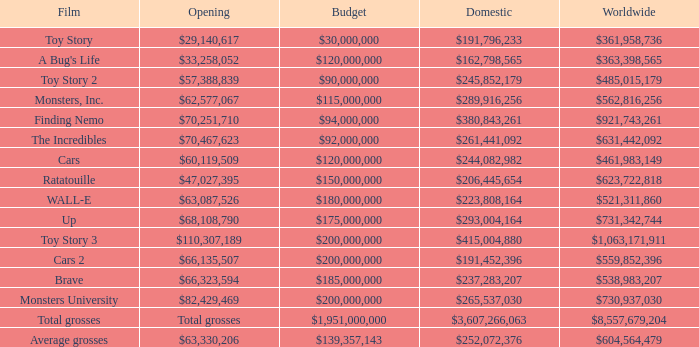What is the global box office revenue for brave? $538,983,207. Could you parse the entire table? {'header': ['Film', 'Opening', 'Budget', 'Domestic', 'Worldwide'], 'rows': [['Toy Story', '$29,140,617', '$30,000,000', '$191,796,233', '$361,958,736'], ["A Bug's Life", '$33,258,052', '$120,000,000', '$162,798,565', '$363,398,565'], ['Toy Story 2', '$57,388,839', '$90,000,000', '$245,852,179', '$485,015,179'], ['Monsters, Inc.', '$62,577,067', '$115,000,000', '$289,916,256', '$562,816,256'], ['Finding Nemo', '$70,251,710', '$94,000,000', '$380,843,261', '$921,743,261'], ['The Incredibles', '$70,467,623', '$92,000,000', '$261,441,092', '$631,442,092'], ['Cars', '$60,119,509', '$120,000,000', '$244,082,982', '$461,983,149'], ['Ratatouille', '$47,027,395', '$150,000,000', '$206,445,654', '$623,722,818'], ['WALL-E', '$63,087,526', '$180,000,000', '$223,808,164', '$521,311,860'], ['Up', '$68,108,790', '$175,000,000', '$293,004,164', '$731,342,744'], ['Toy Story 3', '$110,307,189', '$200,000,000', '$415,004,880', '$1,063,171,911'], ['Cars 2', '$66,135,507', '$200,000,000', '$191,452,396', '$559,852,396'], ['Brave', '$66,323,594', '$185,000,000', '$237,283,207', '$538,983,207'], ['Monsters University', '$82,429,469', '$200,000,000', '$265,537,030', '$730,937,030'], ['Total grosses', 'Total grosses', '$1,951,000,000', '$3,607,266,063', '$8,557,679,204'], ['Average grosses', '$63,330,206', '$139,357,143', '$252,072,376', '$604,564,479']]} 